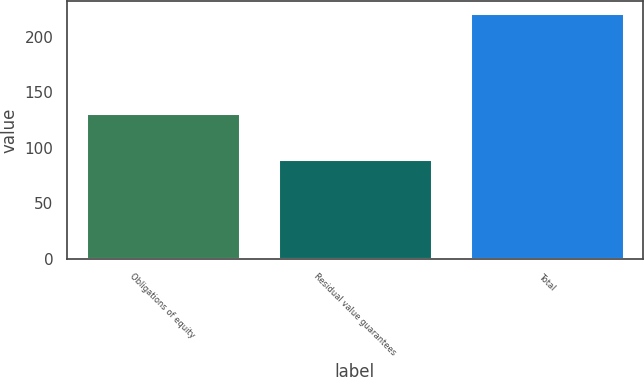Convert chart. <chart><loc_0><loc_0><loc_500><loc_500><bar_chart><fcel>Obligations of equity<fcel>Residual value guarantees<fcel>Total<nl><fcel>131<fcel>90<fcel>221<nl></chart> 